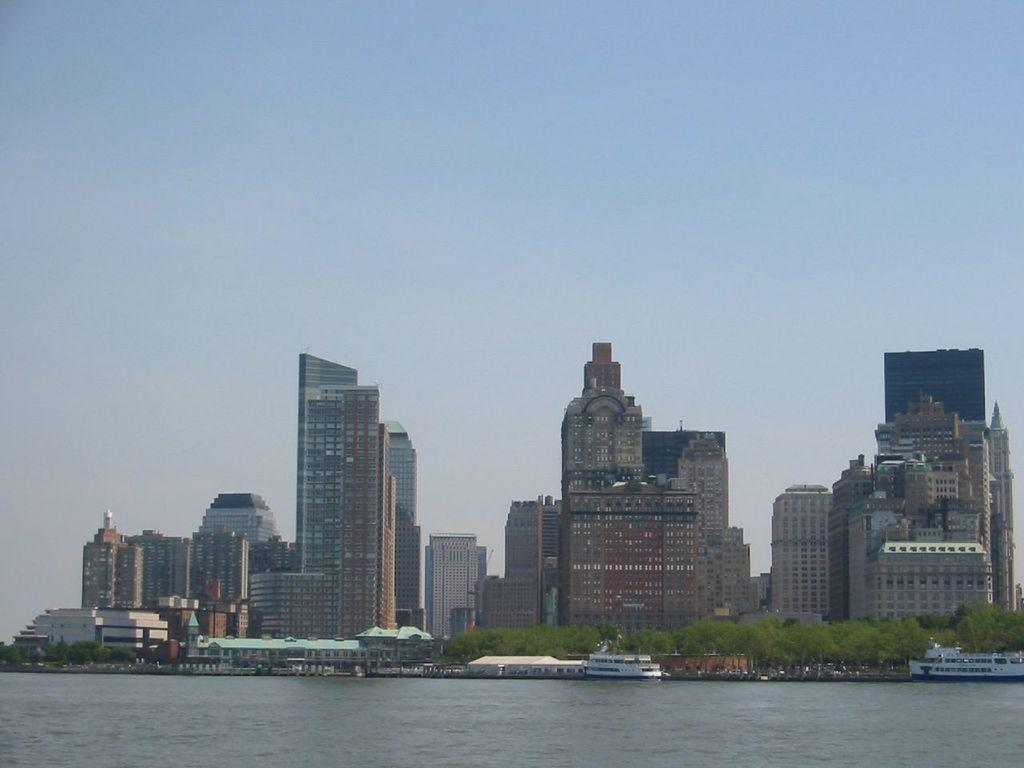What is in the water in the image? There are ships in the water in the image. What can be seen in the background of the image? There are buildings, trees, and the sky visible in the background of the image. What type of clothes does the father wear in the image? There is no father present in the image, so it is not possible to answer that question. 